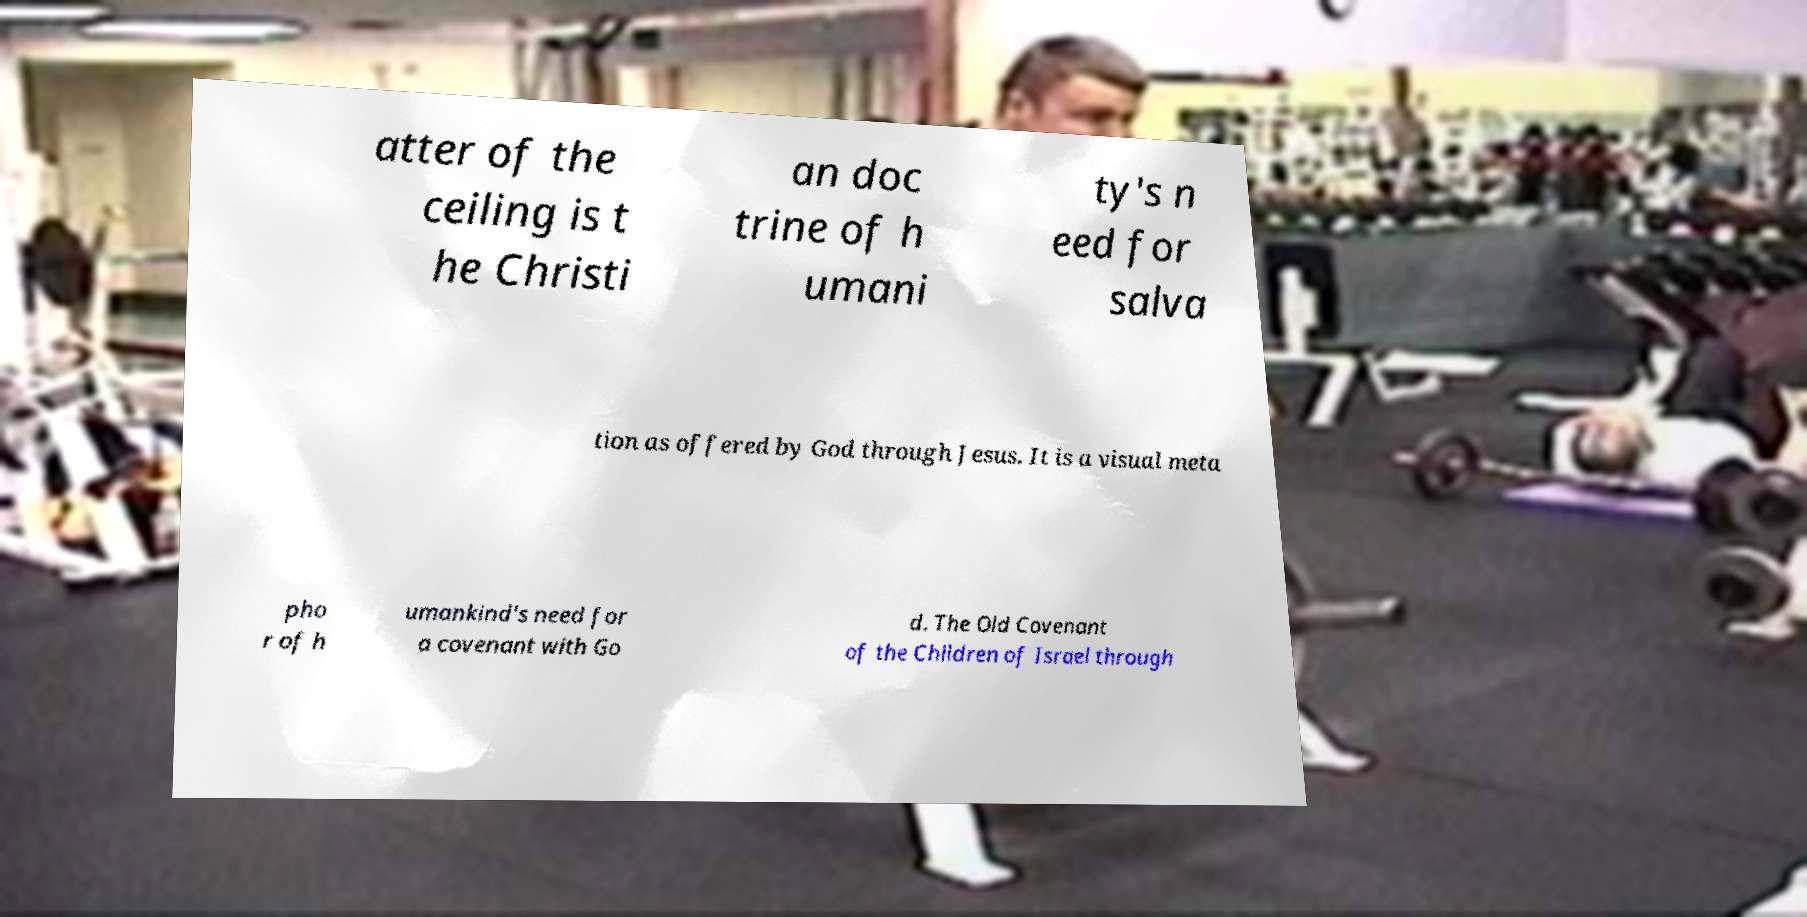I need the written content from this picture converted into text. Can you do that? atter of the ceiling is t he Christi an doc trine of h umani ty's n eed for salva tion as offered by God through Jesus. It is a visual meta pho r of h umankind's need for a covenant with Go d. The Old Covenant of the Children of Israel through 